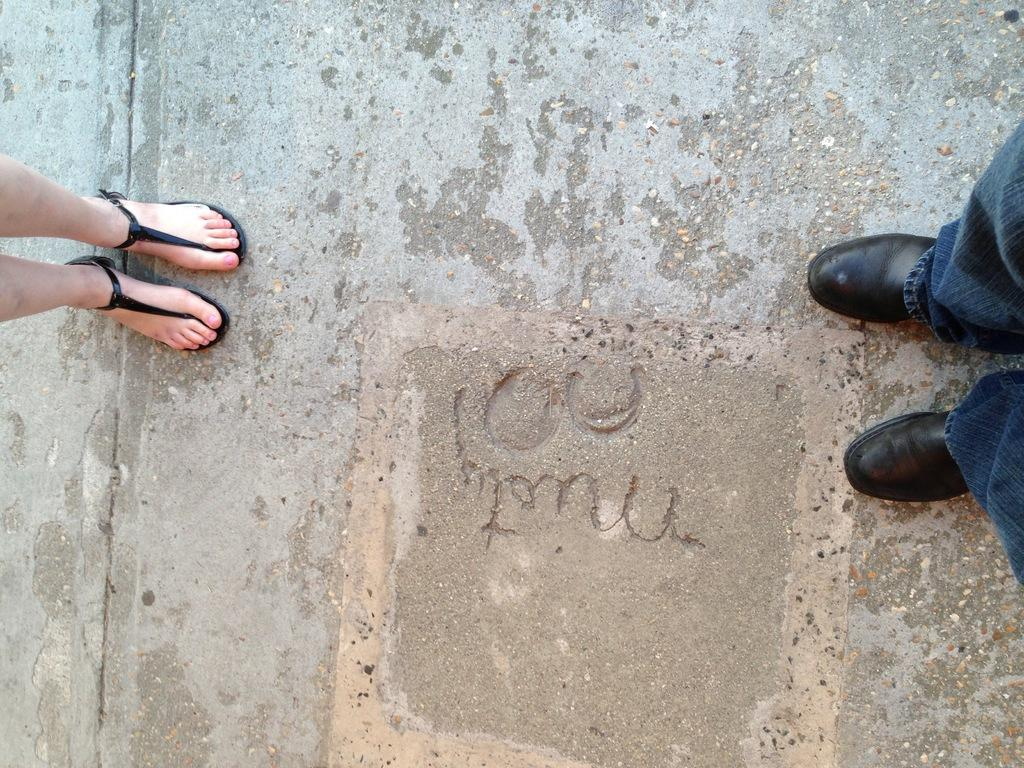How many people are in the image? There are two persons in the image. What are the persons doing in the image? The persons are standing on a road. What type of lace can be seen on the star in the image? There is no star or lace present in the image; it features two persons standing on a road. 